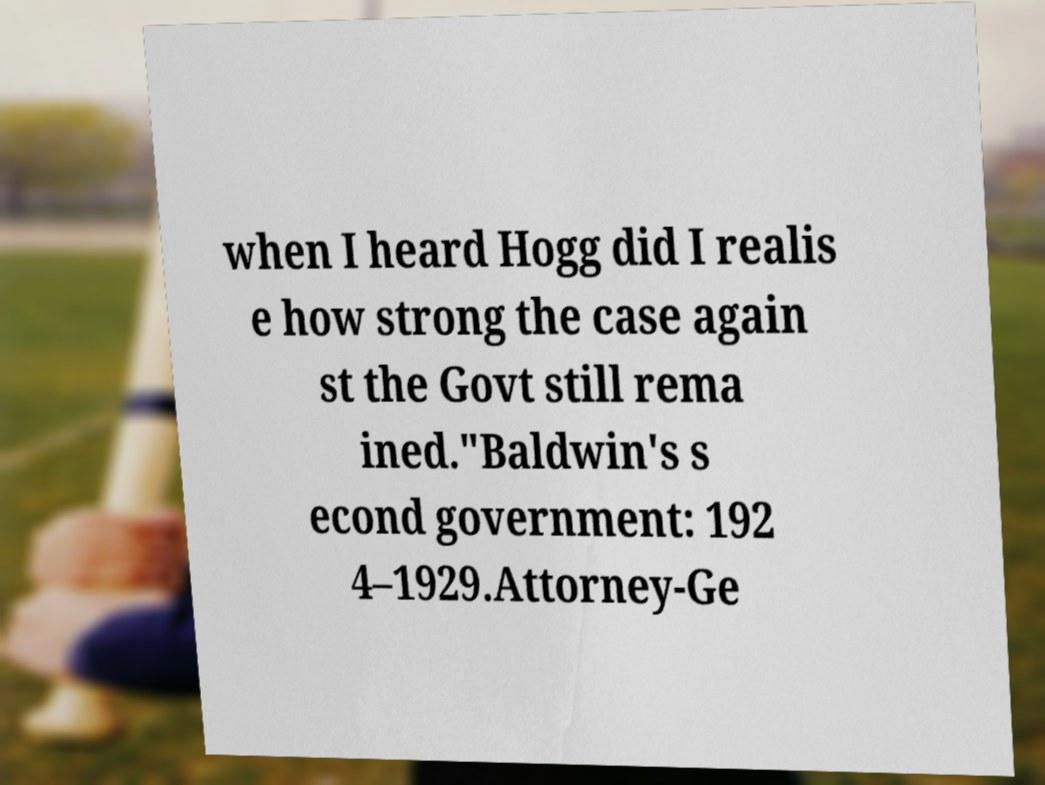Please read and relay the text visible in this image. What does it say? when I heard Hogg did I realis e how strong the case again st the Govt still rema ined."Baldwin's s econd government: 192 4–1929.Attorney-Ge 